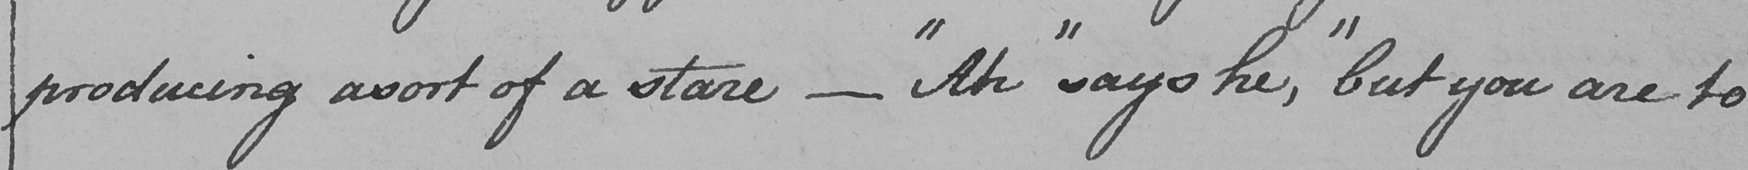Can you read and transcribe this handwriting? producing asort of a stare  _   " Ah "  says he ,  " but you are to 